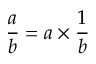Convert formula to latex. <formula><loc_0><loc_0><loc_500><loc_500>{ \frac { a } { b } } = a \times { \frac { 1 } { b } }</formula> 